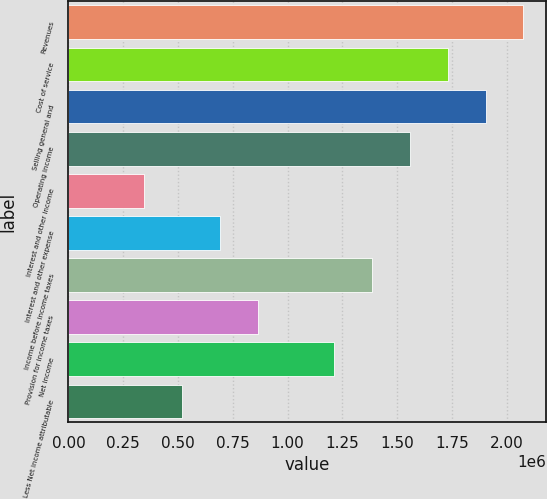<chart> <loc_0><loc_0><loc_500><loc_500><bar_chart><fcel>Revenues<fcel>Cost of service<fcel>Selling general and<fcel>Operating income<fcel>Interest and other income<fcel>Interest and other expense<fcel>Income before income taxes<fcel>Provision for income taxes<fcel>Net income<fcel>Less Net income attributable<nl><fcel>2.07608e+06<fcel>1.73007e+06<fcel>1.90308e+06<fcel>1.55706e+06<fcel>346015<fcel>692029<fcel>1.38406e+06<fcel>865036<fcel>1.21105e+06<fcel>519022<nl></chart> 